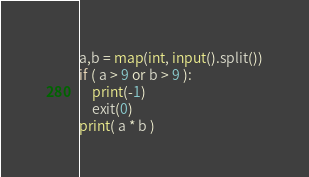<code> <loc_0><loc_0><loc_500><loc_500><_Python_>a,b = map(int, input().split())
if ( a > 9 or b > 9 ):
    print(-1)
    exit(0)
print( a * b )</code> 